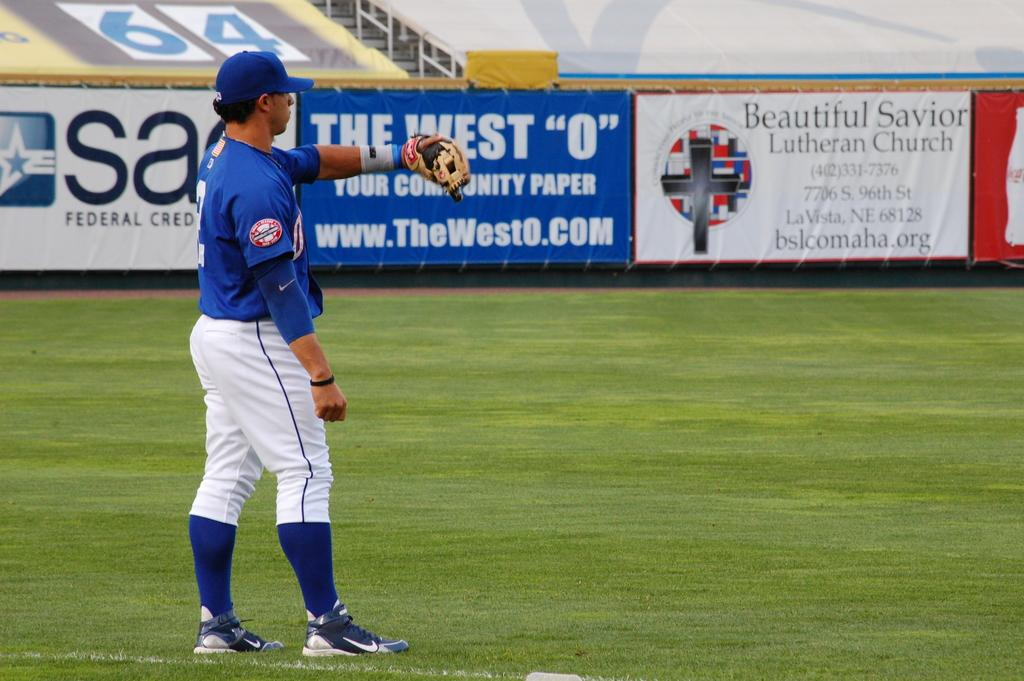<image>
Describe the image concisely. A baseball player in the outfield is waiting to catch a ball by a Federal Credit sign. 